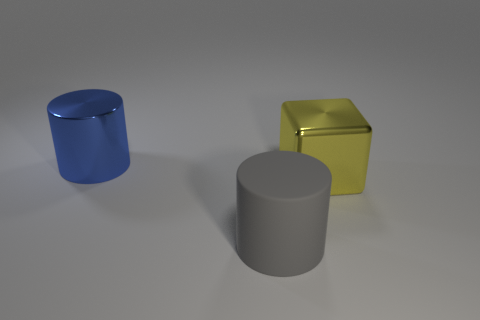Add 1 rubber objects. How many objects exist? 4 Subtract all blocks. How many objects are left? 2 Subtract 0 red cylinders. How many objects are left? 3 Subtract all gray things. Subtract all big yellow cubes. How many objects are left? 1 Add 1 blue cylinders. How many blue cylinders are left? 2 Add 1 matte cylinders. How many matte cylinders exist? 2 